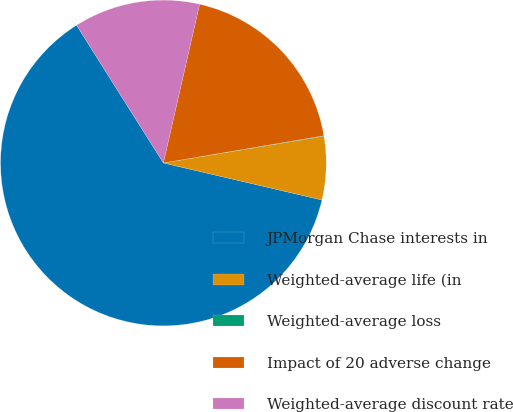Convert chart to OTSL. <chart><loc_0><loc_0><loc_500><loc_500><pie_chart><fcel>JPMorgan Chase interests in<fcel>Weighted-average life (in<fcel>Weighted-average loss<fcel>Impact of 20 adverse change<fcel>Weighted-average discount rate<nl><fcel>62.4%<fcel>6.28%<fcel>0.05%<fcel>18.75%<fcel>12.52%<nl></chart> 